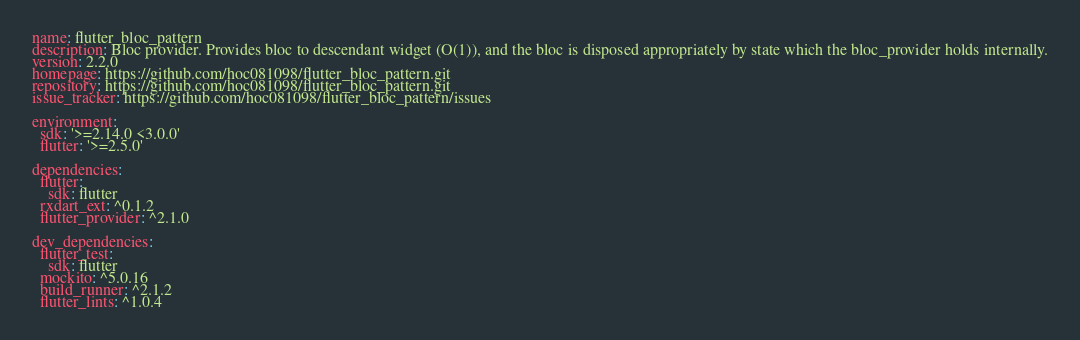Convert code to text. <code><loc_0><loc_0><loc_500><loc_500><_YAML_>name: flutter_bloc_pattern
description: Bloc provider. Provides bloc to descendant widget (O(1)), and the bloc is disposed appropriately by state which the bloc_provider holds internally.
version: 2.2.0
homepage: https://github.com/hoc081098/flutter_bloc_pattern.git
repository: https://github.com/hoc081098/flutter_bloc_pattern.git
issue_tracker: https://github.com/hoc081098/flutter_bloc_pattern/issues

environment:
  sdk: '>=2.14.0 <3.0.0'
  flutter: '>=2.5.0'

dependencies:
  flutter:
    sdk: flutter
  rxdart_ext: ^0.1.2
  flutter_provider: ^2.1.0

dev_dependencies:
  flutter_test:
    sdk: flutter
  mockito: ^5.0.16
  build_runner: ^2.1.2
  flutter_lints: ^1.0.4
</code> 